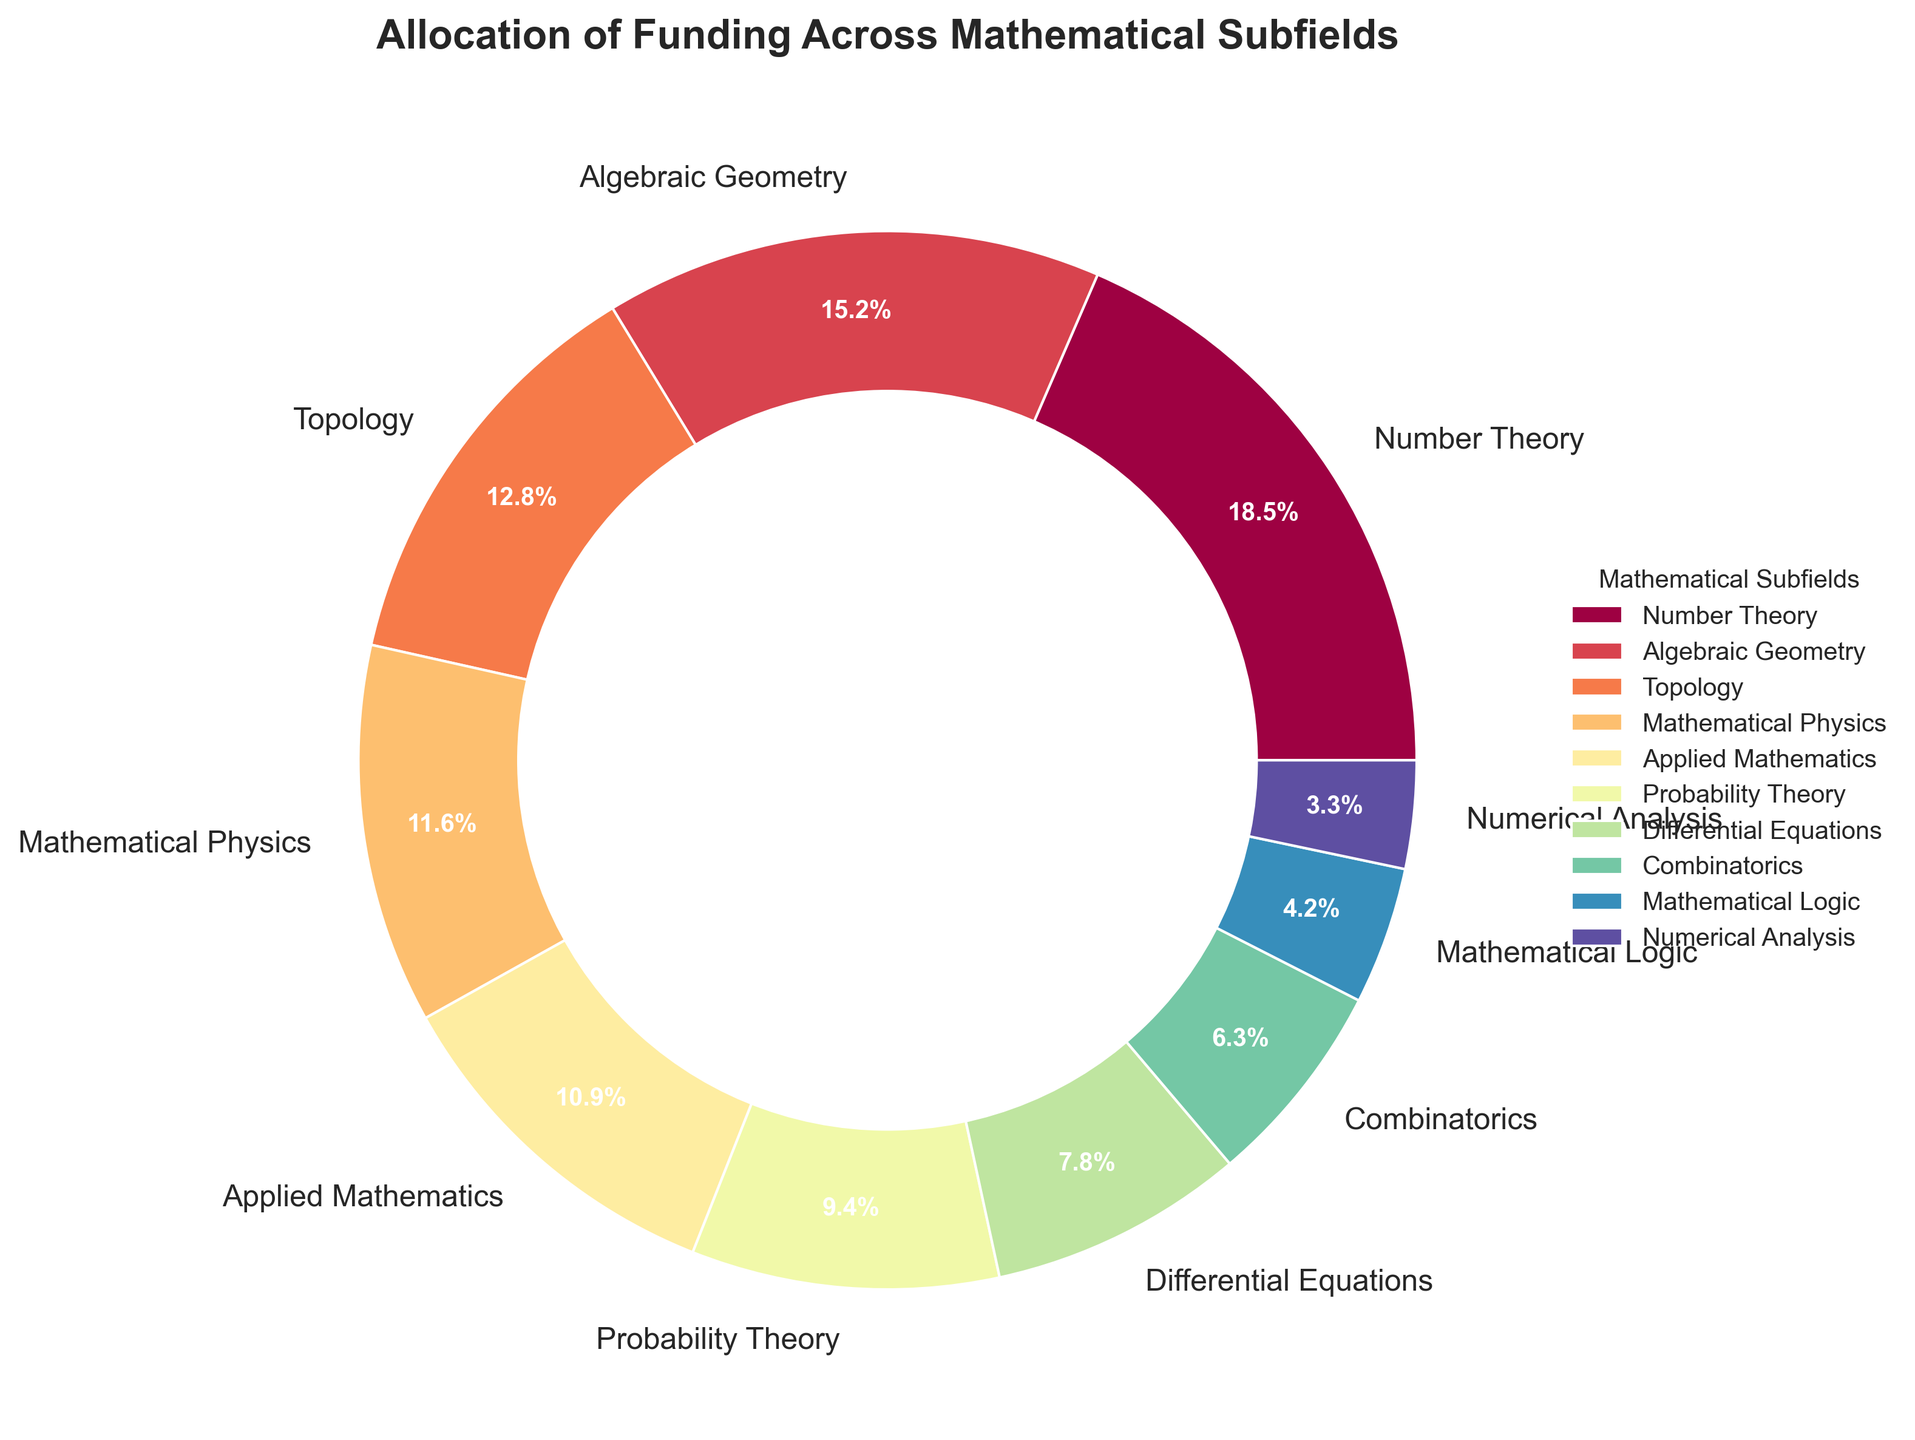Which subfield receives the highest percentage of funding? The slice labeled "Number Theory" is the largest, indicating it receives the highest funding percentage.
Answer: Number Theory What is the total percentage of funding allocated to Probability Theory and Mathematical Logic combined? Add the percentages for Probability Theory (9.4) and Mathematical Logic (4.2). 9.4 + 4.2 = 13.6%
Answer: 13.6% Are there more funds allocated to Applied Mathematics or Topology? Applied Mathematics has a percentage of 10.9, while Topology has 12.8. Thus, Topology receives more funding.
Answer: Topology Which subfield receives less funding: Differential Equations or Combinatorics? Compare the percentages for Differential Equations (7.8) and Combinatorics (6.3). Combinatorics receives less funding.
Answer: Combinatorics What percentage of the funding is allocated to subfields that have a portion less than 10% each? Sum the percentages of the subfields with less than 10%: Applied Mathematics (10.9), Probability Theory (9.4), Differential Equations (7.8), Combinatorics (6.3), Mathematical Logic (4.2), and Numerical Analysis (3.3). 9.4 + 7.8 + 6.3 + 4.2 + 3.3 = 31.0%
Answer: 31.0% How does the funding allocated to Algebraic Geometry compare to that of Mathematical Physics? Algebraic Geometry has 15.2%, whereas Mathematical Physics has 11.6%. Algebraic Geometry receives more.
Answer: Algebraic Geometry receives more Identify three subfields with funding percentages below 8%. Looking at the pie chart, the subfields with funding percentages below 8% are Differential Equations (7.8), Combinatorics (6.3), and Mathematical Logic (4.2).
Answer: Differential Equations, Combinatorics, Mathematical Logic Calculate the average funding percentage for Number Theory, Algebraic Geometry, and Topology. Add the percentages for Number Theory (18.5), Algebraic Geometry (15.2), and Topology (12.8) and divide by 3. (18.5 + 15.2 + 12.8) / 3 = 15.5%
Answer: 15.5% What is the difference in funding percentage between the highest and lowest funded subfields? The highest is Number Theory (18.5) and the lowest is Numerical Analysis (3.3). Subtract them: 18.5 - 3.3 = 15.2%
Answer: 15.2% Which subfield has the second-lowest funding percentage and what is that percentage? Numerical Analysis has the lowest (3.3%). The second-lowest is Mathematical Logic with 4.2%.
Answer: Mathematical Logic, 4.2% 